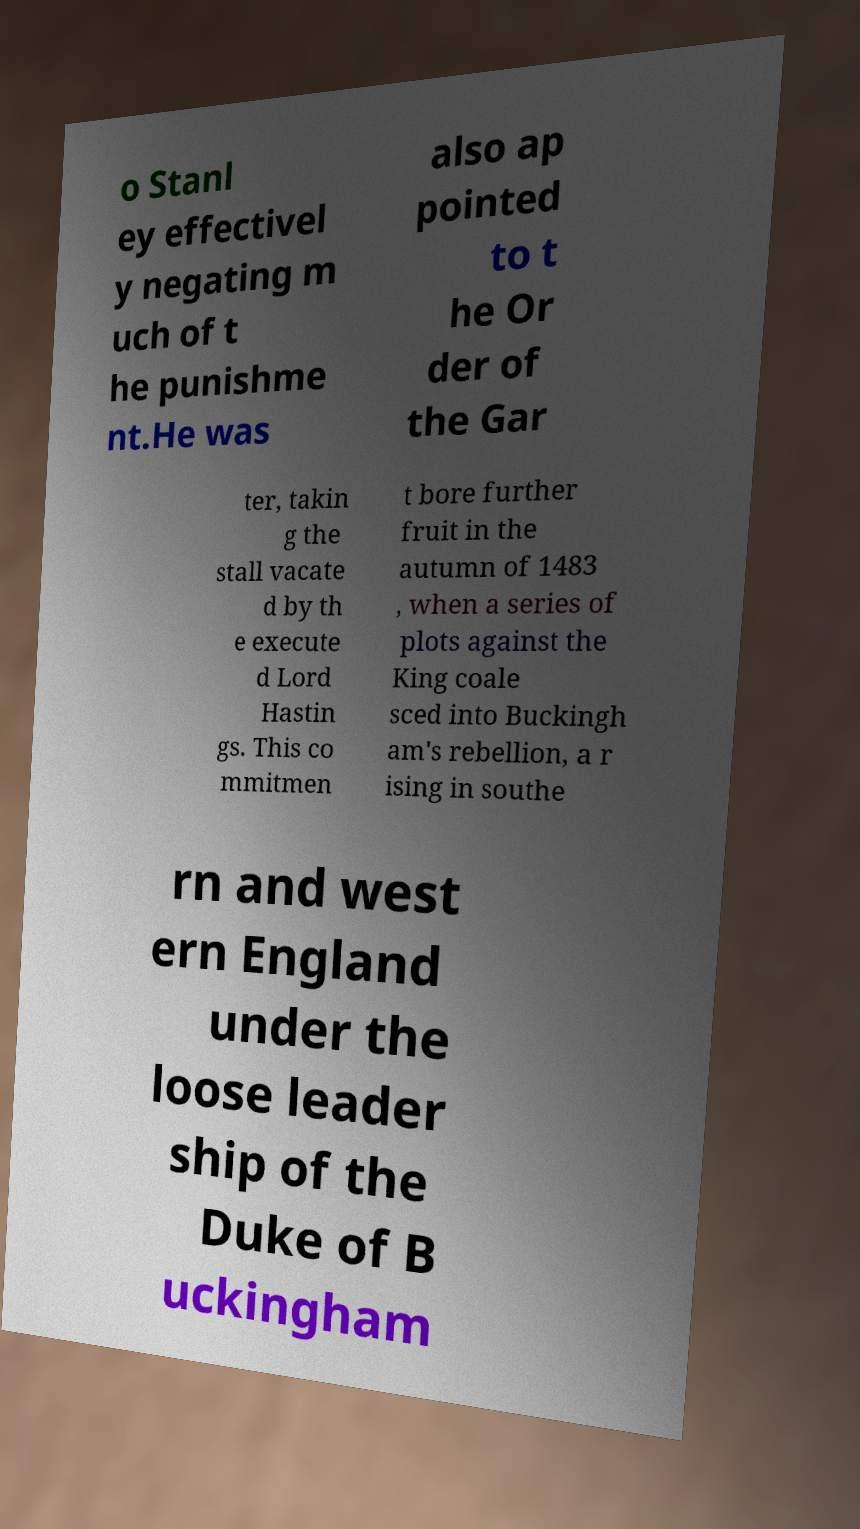For documentation purposes, I need the text within this image transcribed. Could you provide that? o Stanl ey effectivel y negating m uch of t he punishme nt.He was also ap pointed to t he Or der of the Gar ter, takin g the stall vacate d by th e execute d Lord Hastin gs. This co mmitmen t bore further fruit in the autumn of 1483 , when a series of plots against the King coale sced into Buckingh am's rebellion, a r ising in southe rn and west ern England under the loose leader ship of the Duke of B uckingham 